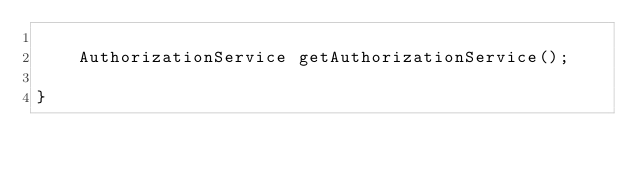Convert code to text. <code><loc_0><loc_0><loc_500><loc_500><_Java_>
    AuthorizationService getAuthorizationService();

}
</code> 